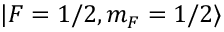Convert formula to latex. <formula><loc_0><loc_0><loc_500><loc_500>| F = 1 / 2 , m _ { F } = 1 / 2 \rangle</formula> 